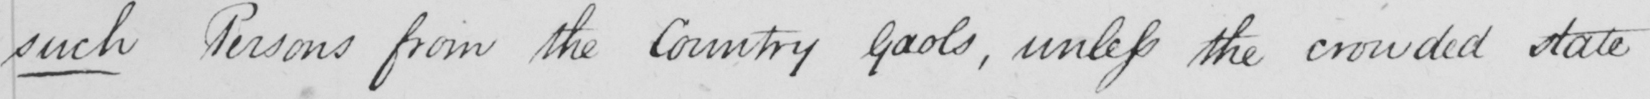Can you read and transcribe this handwriting? such Persons from the country Gaols , unless the crowded state 